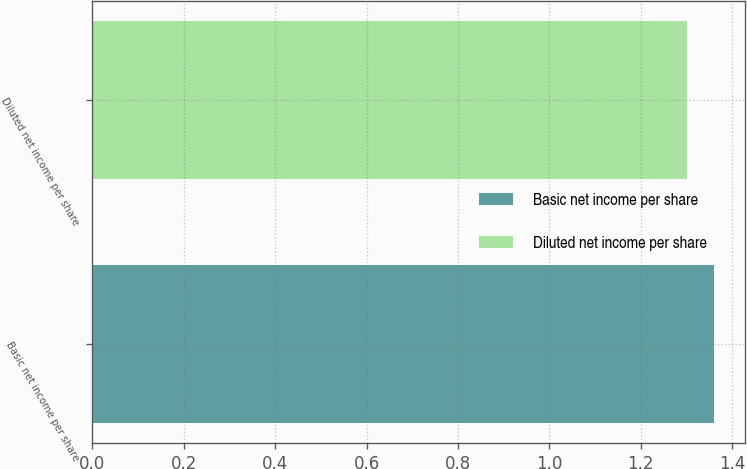Convert chart. <chart><loc_0><loc_0><loc_500><loc_500><bar_chart><fcel>Basic net income per share<fcel>Diluted net income per share<nl><fcel>1.36<fcel>1.3<nl></chart> 